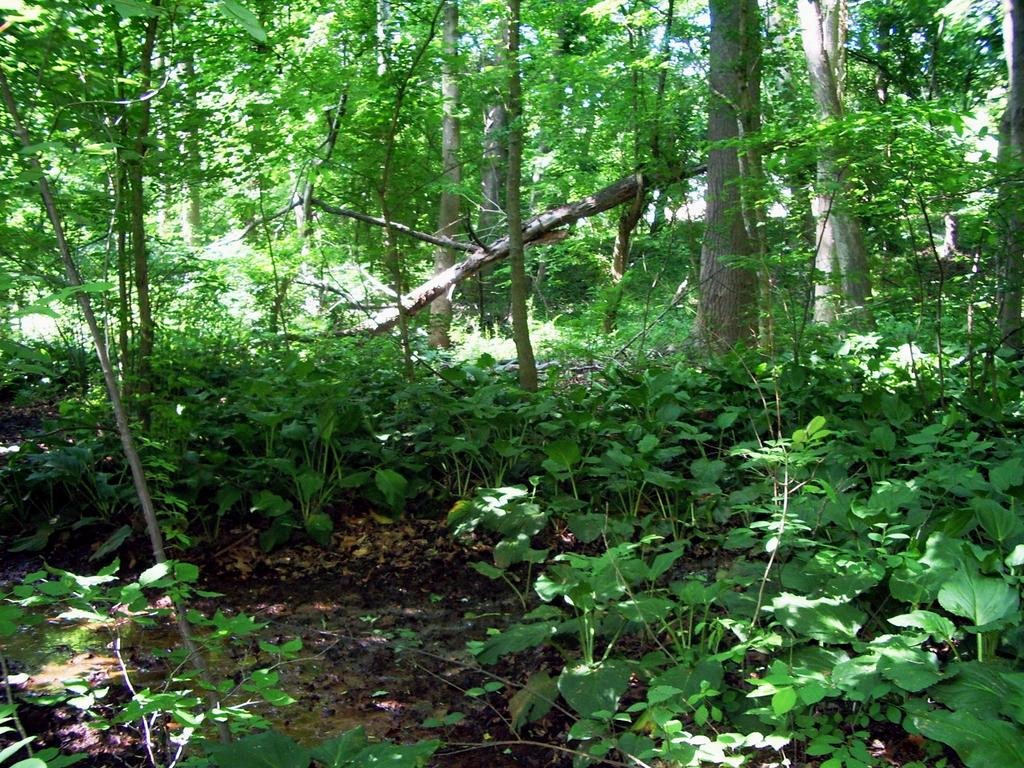What type of vegetation can be seen in the image? There are plants and trees in the image. Can you describe the plants and trees in more detail? Unfortunately, the facts provided do not give more specific details about the plants and trees. What is the setting or location of the image? The facts provided do not give information about the setting or location of the image. What type of sign can be seen in the image? There is no sign present in the image; it only features plants and trees. How is the distribution of the plants and trees in the image? The facts provided do not give information about the distribution of the plants and trees in the image. 